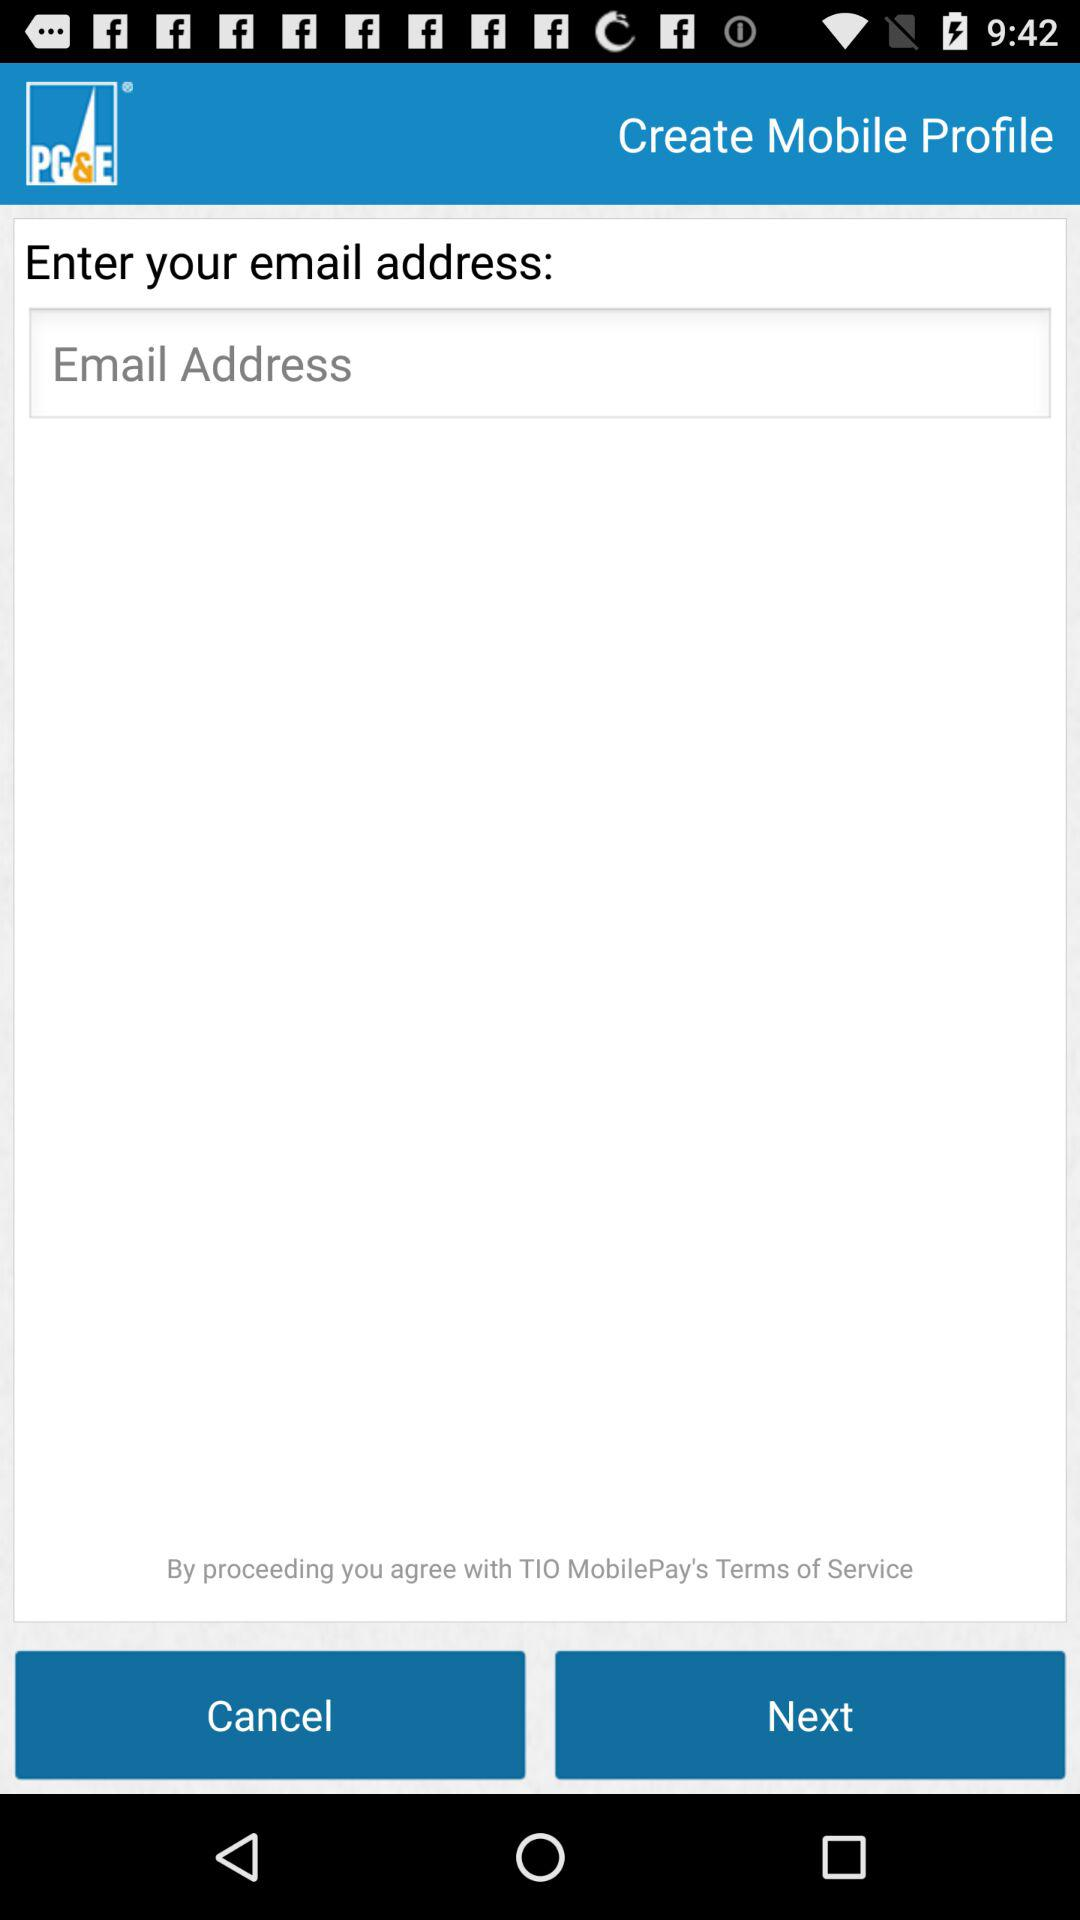What is the company name? The company name is "Pacific Gas and Electric Company". 